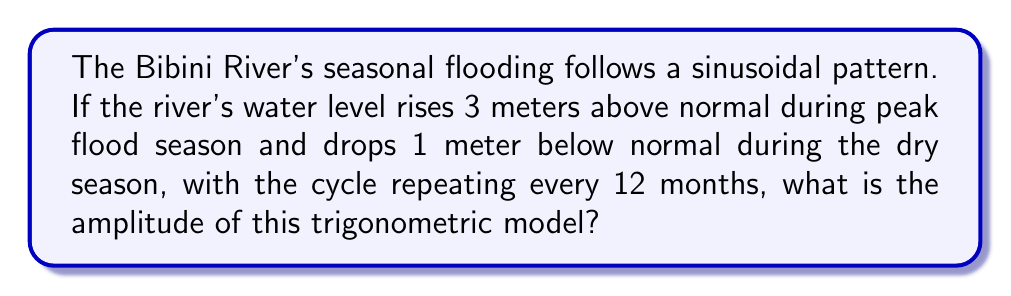Help me with this question. Let's approach this step-by-step:

1) The trigonometric model for periodic flooding can be represented by a sine or cosine function:

   $$y = A \sin(Bt) + C$$

   where $A$ is the amplitude, $B$ is the angular frequency, $t$ is time, and $C$ is the vertical shift.

2) We're asked to find the amplitude $A$. In a sine or cosine function, the amplitude is half the distance between the maximum and minimum values.

3) From the question:
   - Peak flood level: 3 meters above normal
   - Lowest water level: 1 meter below normal

4) To calculate the amplitude:
   $$A = \frac{\text{Max} - \text{Min}}{2}$$

5) Substituting the values:
   $$A = \frac{3 - (-1)}{2} = \frac{4}{2} = 2$$

Therefore, the amplitude of the trigonometric model is 2 meters.
Answer: 2 meters 